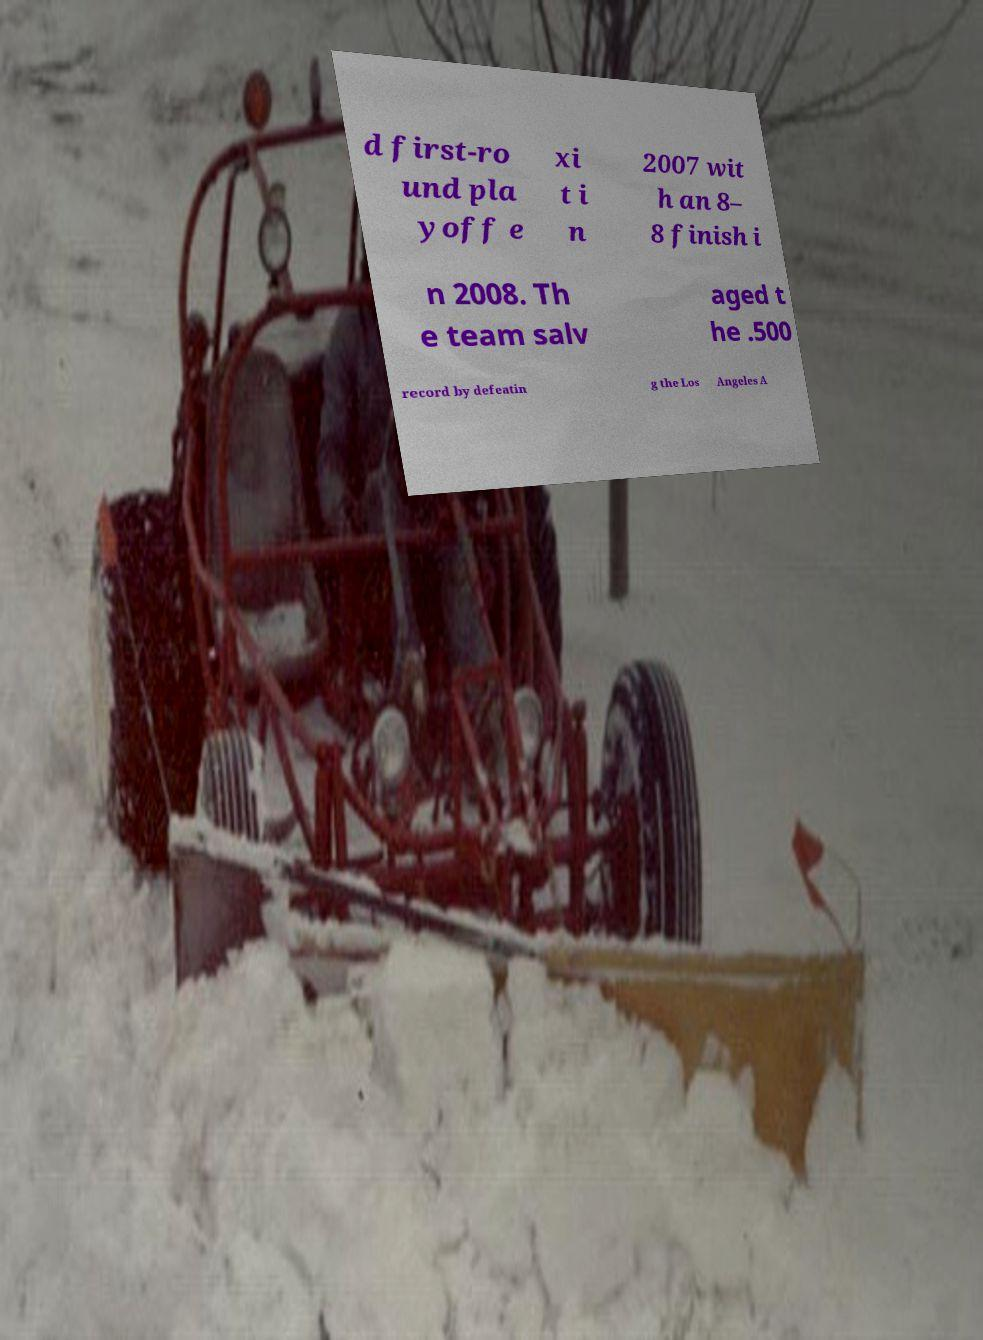Please identify and transcribe the text found in this image. d first-ro und pla yoff e xi t i n 2007 wit h an 8– 8 finish i n 2008. Th e team salv aged t he .500 record by defeatin g the Los Angeles A 